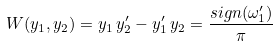Convert formula to latex. <formula><loc_0><loc_0><loc_500><loc_500>W ( y _ { 1 } , y _ { 2 } ) = y _ { 1 } \, y _ { 2 } ^ { \prime } - y _ { 1 } ^ { \prime } \, y _ { 2 } = \frac { s i g n ( \omega _ { 1 } ^ { \prime } ) } { \pi }</formula> 